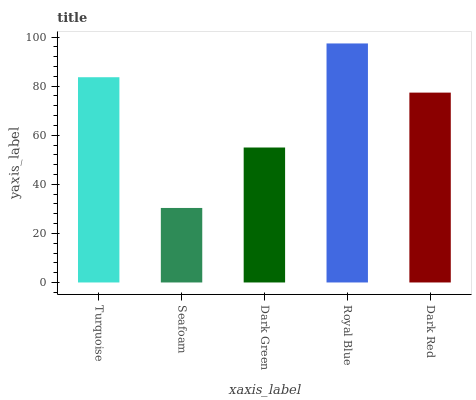Is Seafoam the minimum?
Answer yes or no. Yes. Is Royal Blue the maximum?
Answer yes or no. Yes. Is Dark Green the minimum?
Answer yes or no. No. Is Dark Green the maximum?
Answer yes or no. No. Is Dark Green greater than Seafoam?
Answer yes or no. Yes. Is Seafoam less than Dark Green?
Answer yes or no. Yes. Is Seafoam greater than Dark Green?
Answer yes or no. No. Is Dark Green less than Seafoam?
Answer yes or no. No. Is Dark Red the high median?
Answer yes or no. Yes. Is Dark Red the low median?
Answer yes or no. Yes. Is Royal Blue the high median?
Answer yes or no. No. Is Seafoam the low median?
Answer yes or no. No. 